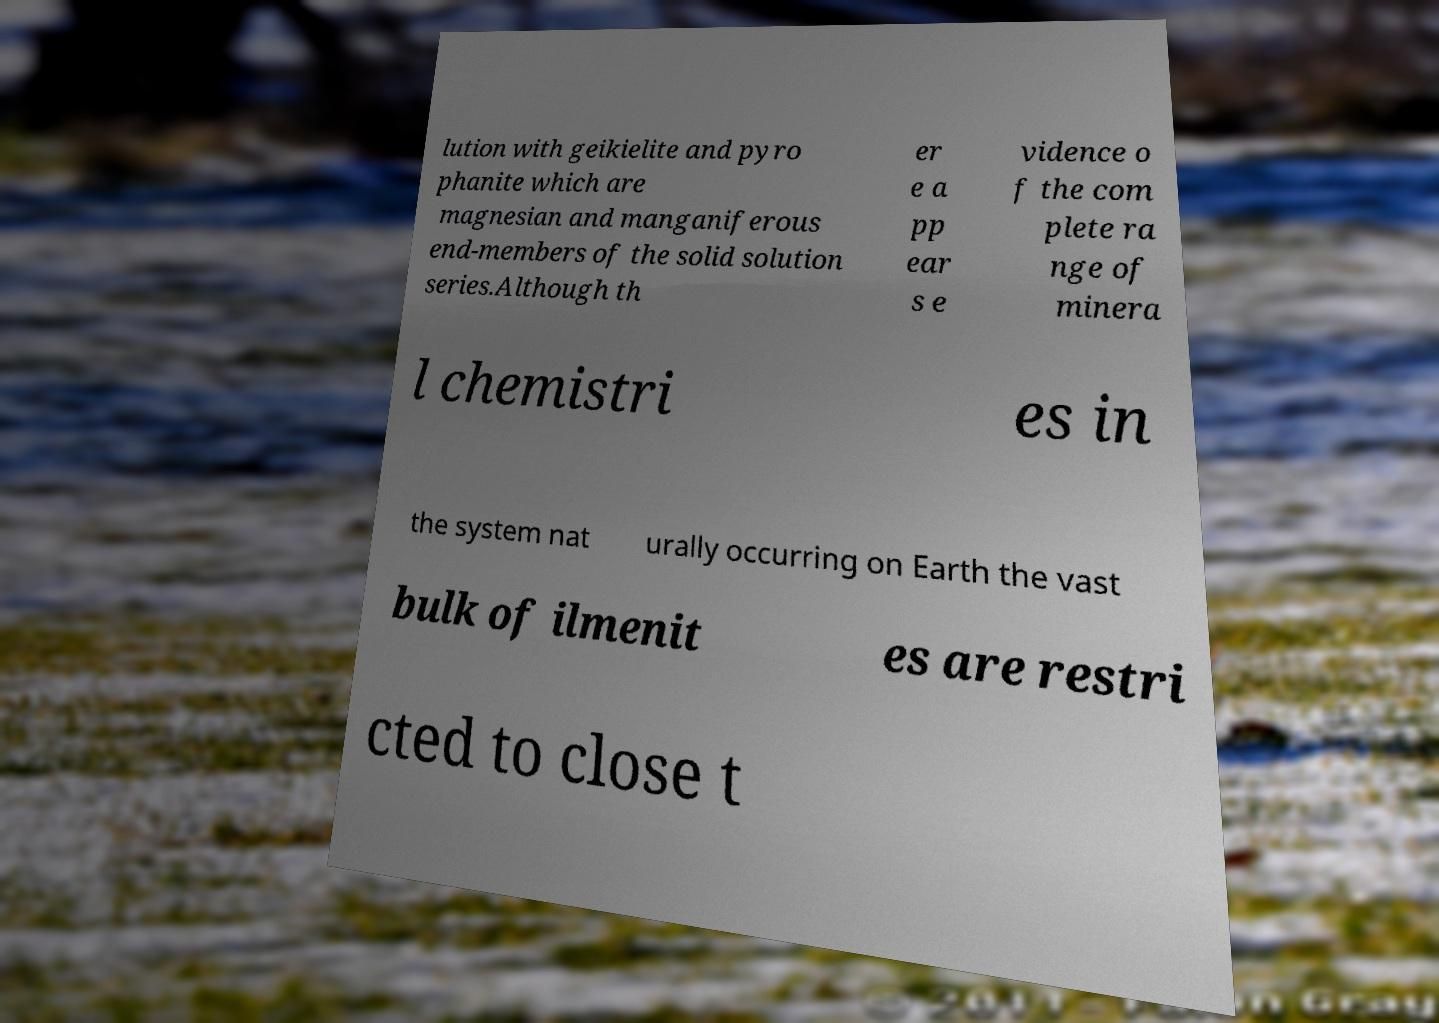Could you assist in decoding the text presented in this image and type it out clearly? lution with geikielite and pyro phanite which are magnesian and manganiferous end-members of the solid solution series.Although th er e a pp ear s e vidence o f the com plete ra nge of minera l chemistri es in the system nat urally occurring on Earth the vast bulk of ilmenit es are restri cted to close t 